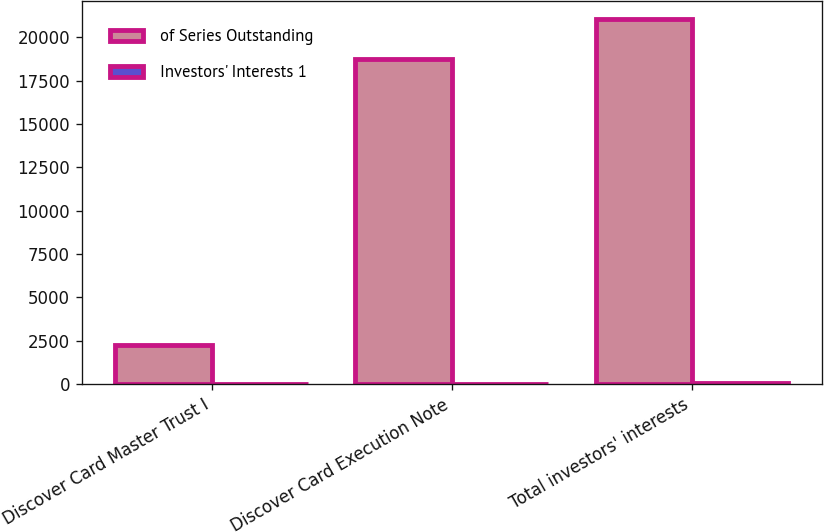<chart> <loc_0><loc_0><loc_500><loc_500><stacked_bar_chart><ecel><fcel>Discover Card Master Trust I<fcel>Discover Card Execution Note<fcel>Total investors' interests<nl><fcel>of Series Outstanding<fcel>2288<fcel>18739<fcel>21027<nl><fcel>Investors' Interests 1<fcel>4<fcel>39<fcel>43<nl></chart> 